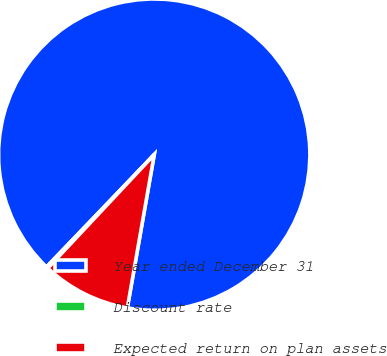Convert chart. <chart><loc_0><loc_0><loc_500><loc_500><pie_chart><fcel>Year ended December 31<fcel>Discount rate<fcel>Expected return on plan assets<nl><fcel>90.6%<fcel>0.18%<fcel>9.22%<nl></chart> 